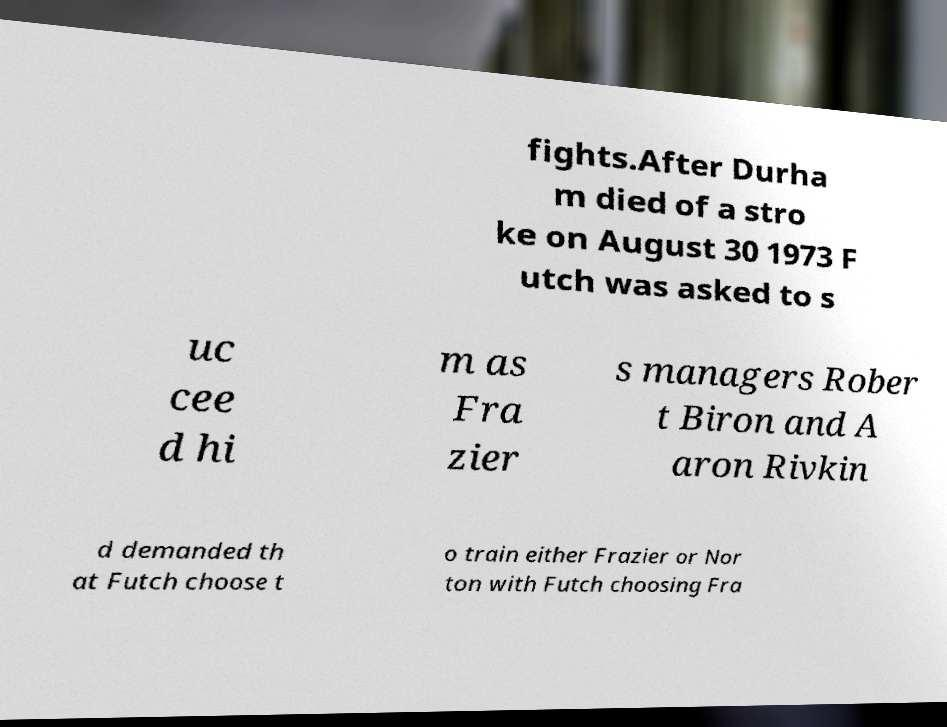What messages or text are displayed in this image? I need them in a readable, typed format. fights.After Durha m died of a stro ke on August 30 1973 F utch was asked to s uc cee d hi m as Fra zier s managers Rober t Biron and A aron Rivkin d demanded th at Futch choose t o train either Frazier or Nor ton with Futch choosing Fra 